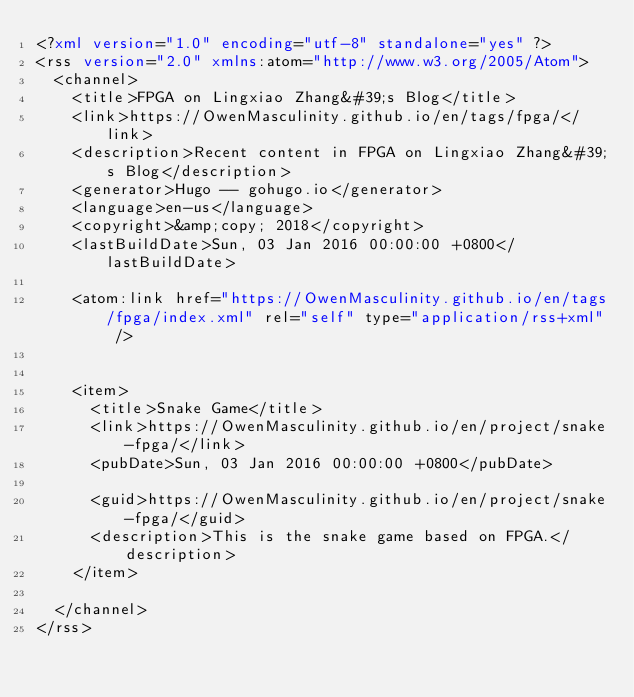<code> <loc_0><loc_0><loc_500><loc_500><_XML_><?xml version="1.0" encoding="utf-8" standalone="yes" ?>
<rss version="2.0" xmlns:atom="http://www.w3.org/2005/Atom">
  <channel>
    <title>FPGA on Lingxiao Zhang&#39;s Blog</title>
    <link>https://OwenMasculinity.github.io/en/tags/fpga/</link>
    <description>Recent content in FPGA on Lingxiao Zhang&#39;s Blog</description>
    <generator>Hugo -- gohugo.io</generator>
    <language>en-us</language>
    <copyright>&amp;copy; 2018</copyright>
    <lastBuildDate>Sun, 03 Jan 2016 00:00:00 +0800</lastBuildDate>
    
	<atom:link href="https://OwenMasculinity.github.io/en/tags/fpga/index.xml" rel="self" type="application/rss+xml" />
    
    
    <item>
      <title>Snake Game</title>
      <link>https://OwenMasculinity.github.io/en/project/snake-fpga/</link>
      <pubDate>Sun, 03 Jan 2016 00:00:00 +0800</pubDate>
      
      <guid>https://OwenMasculinity.github.io/en/project/snake-fpga/</guid>
      <description>This is the snake game based on FPGA.</description>
    </item>
    
  </channel>
</rss></code> 